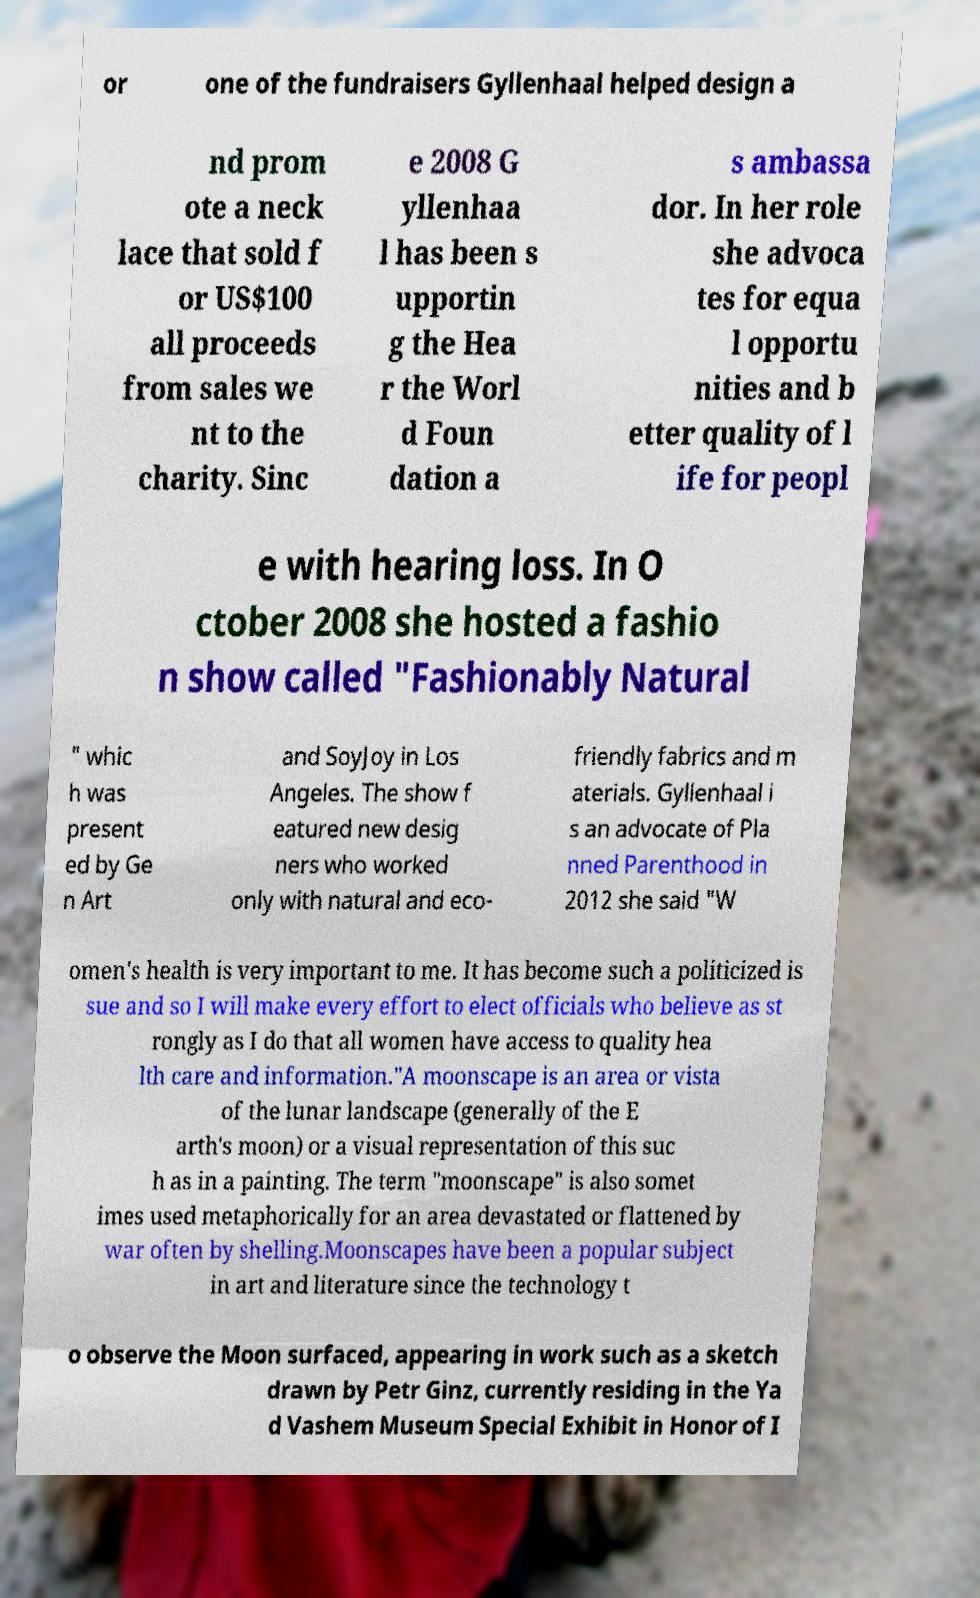There's text embedded in this image that I need extracted. Can you transcribe it verbatim? or one of the fundraisers Gyllenhaal helped design a nd prom ote a neck lace that sold f or US$100 all proceeds from sales we nt to the charity. Sinc e 2008 G yllenhaa l has been s upportin g the Hea r the Worl d Foun dation a s ambassa dor. In her role she advoca tes for equa l opportu nities and b etter quality of l ife for peopl e with hearing loss. In O ctober 2008 she hosted a fashio n show called "Fashionably Natural " whic h was present ed by Ge n Art and SoyJoy in Los Angeles. The show f eatured new desig ners who worked only with natural and eco- friendly fabrics and m aterials. Gyllenhaal i s an advocate of Pla nned Parenthood in 2012 she said "W omen's health is very important to me. It has become such a politicized is sue and so I will make every effort to elect officials who believe as st rongly as I do that all women have access to quality hea lth care and information."A moonscape is an area or vista of the lunar landscape (generally of the E arth's moon) or a visual representation of this suc h as in a painting. The term "moonscape" is also somet imes used metaphorically for an area devastated or flattened by war often by shelling.Moonscapes have been a popular subject in art and literature since the technology t o observe the Moon surfaced, appearing in work such as a sketch drawn by Petr Ginz, currently residing in the Ya d Vashem Museum Special Exhibit in Honor of I 